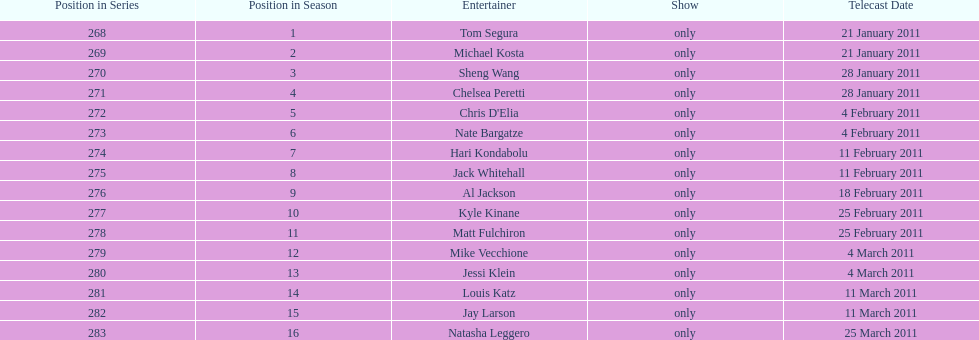How many comedians made their only appearance on comedy central presents in season 15? 16. 